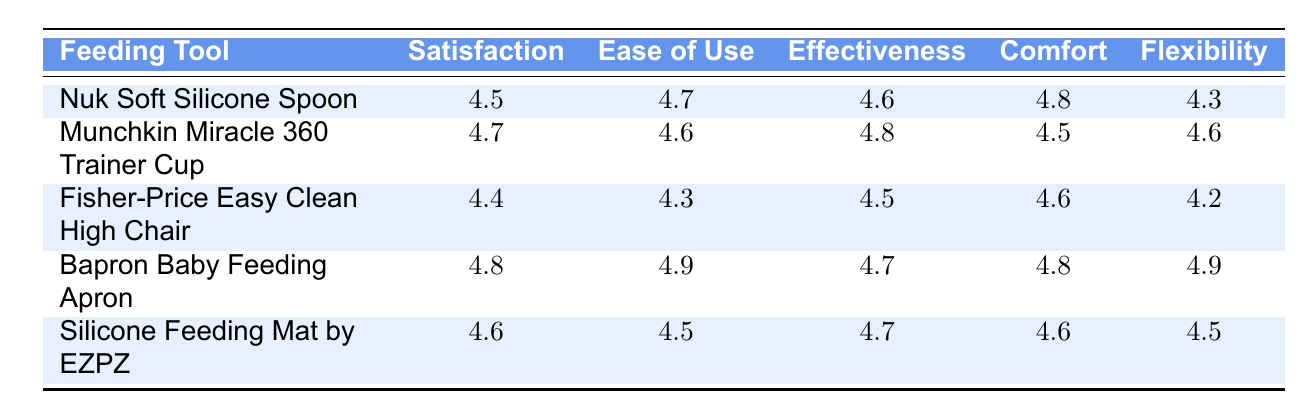What is the parent satisfaction rating for the Munchkin Miracle 360 Trainer Cup? The table lists the parent satisfaction rating for the Munchkin Miracle 360 Trainer Cup as 4.7.
Answer: 4.7 Which feeding tool has the highest comfort rating? By comparing the comfort ratings in the table, the Bapron Baby Feeding Apron has the highest comfort rating at 4.8.
Answer: Bapron Baby Feeding Apron Is the effectiveness rating for the Silicone Feeding Mat by EZPZ higher than 4.6? The effectiveness rating for the Silicone Feeding Mat by EZPZ is 4.7, which is higher than 4.6. Thus, the statement is true.
Answer: Yes What is the average parent satisfaction rating of all the feeding tools listed? The satisfaction ratings are 4.5, 4.7, 4.4, 4.8, and 4.6. Summing these gives 4.5 + 4.7 + 4.4 + 4.8 + 4.6 = 24.0. There are 5 feeding tools, so the average is 24.0 / 5 = 4.8.
Answer: 4.8 Is there any tool that has a flexibility rating of 4.9? Yes, the Bapron Baby Feeding Apron has a flexibility rating of 4.9. Therefore, the answer is true to the question.
Answer: Yes Which tool has the lowest ease of use rating, and what is that rating? The Fisher-Price Easy Clean High Chair has the lowest ease of use rating at 4.3, which can be seen by comparing the values in the respective column.
Answer: Fisher-Price Easy Clean High Chair, 4.3 What is the difference in the comfort ratings between the Nuk Soft Silicone Spoon and the Bapron Baby Feeding Apron? The comfort rating for the Nuk Soft Silicone Spoon is 4.8 and for the Bapron Baby Feeding Apron it is also 4.8. Therefore, the difference is 4.8 - 4.8 = 0.
Answer: 0 Which feeding tool has both the highest ease of use and flexibility ratings? The Bapron Baby Feeding Apron has the highest ratings of 4.9 in ease of use and 4.9 in flexibility, making it the only tool to achieve the highest in both categories.
Answer: Bapron Baby Feeding Apron 